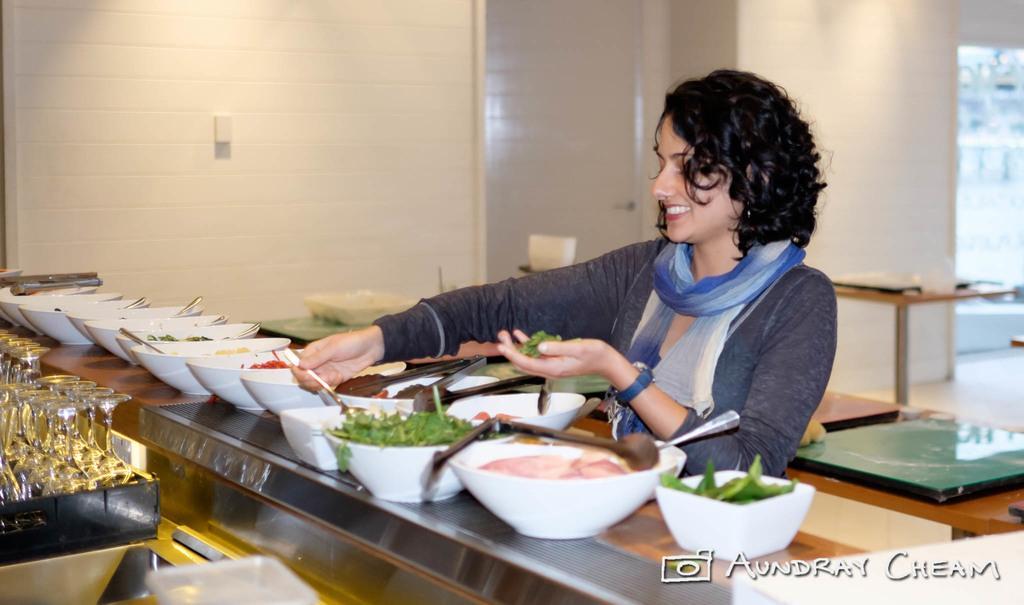Could you give a brief overview of what you see in this image? In this image we can see a platform. On that there are bowls with food items and spoons. Also there are tongs. And there is a lady holding spoon in one hand and food item in other hand. In the back there is a wall. And there is a platform and table. And we can see glasses in a tray. And there is watermark in the right bottom corner. 